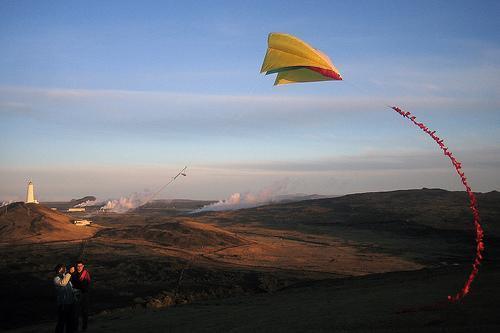How many people are there?
Give a very brief answer. 2. 